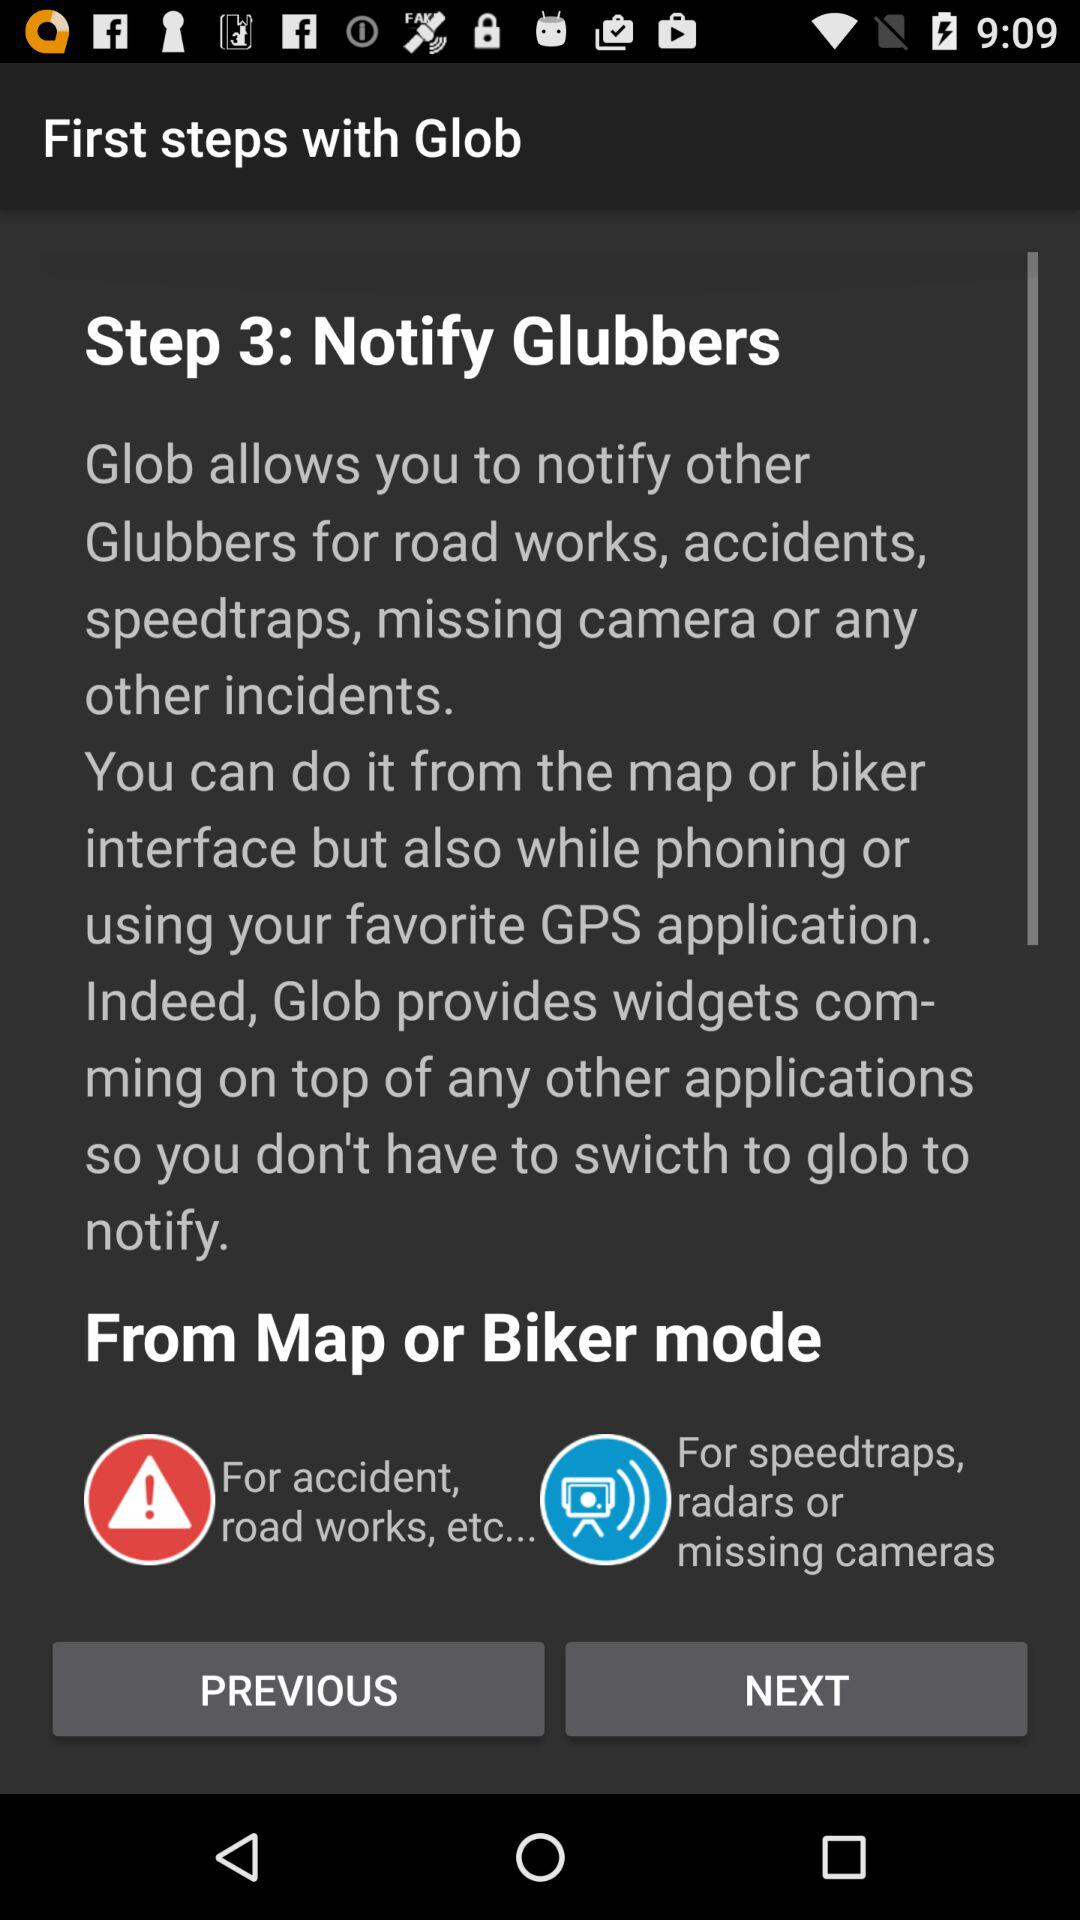What is the step three? The third step is "Notify Glubbers". 